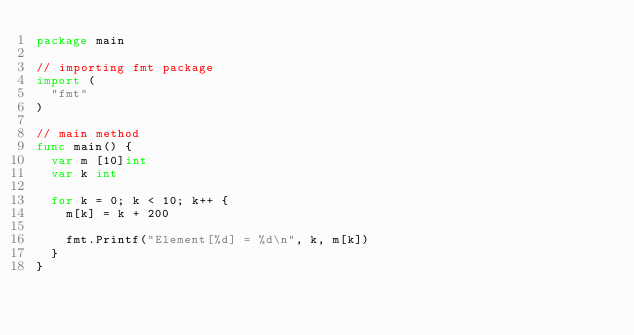<code> <loc_0><loc_0><loc_500><loc_500><_Go_>package main

// importing fmt package
import (
	"fmt"
)

// main method
func main() {
	var m [10]int
	var k int

	for k = 0; k < 10; k++ {
		m[k] = k + 200

		fmt.Printf("Element[%d] = %d\n", k, m[k])
	}
}
</code> 